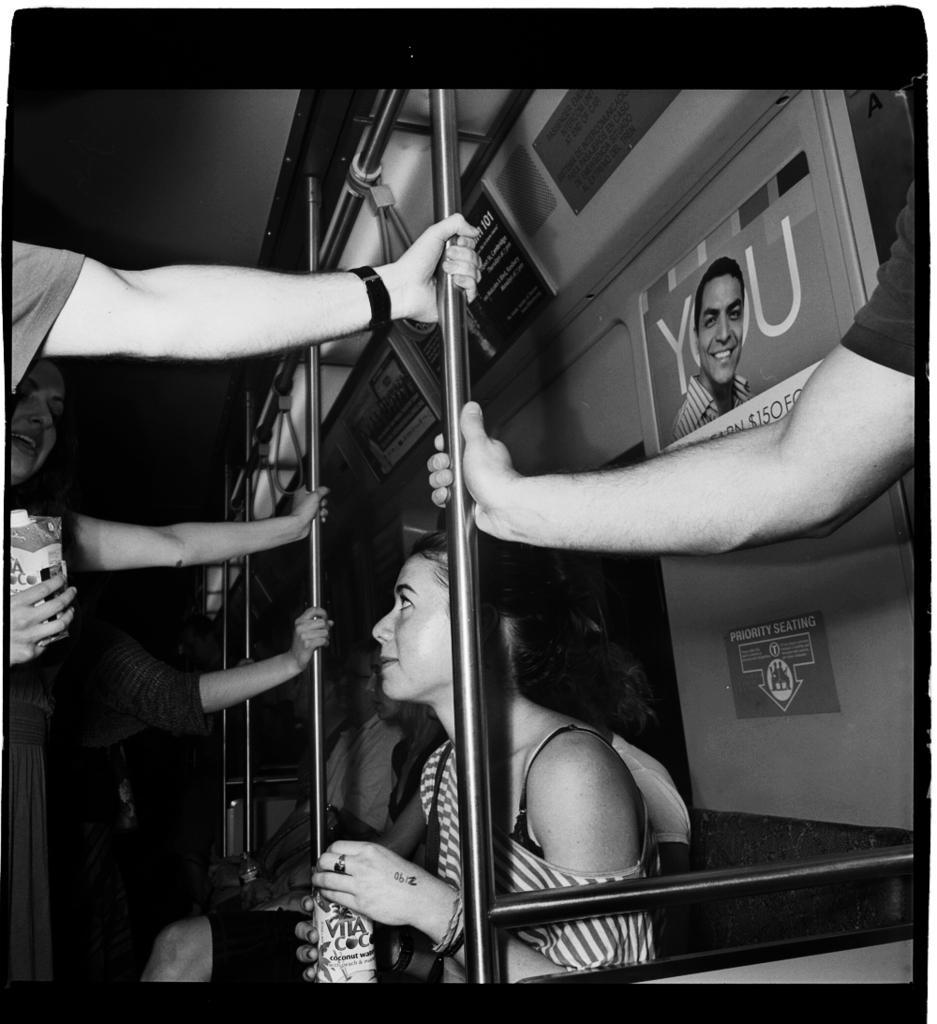Could you give a brief overview of what you see in this image? It looks like a black and white picture. We can see some people are standing and holding the iron rods and some people are sitting. On the right side of the people there are posters inside of a vehicle and two people are holding some objects. 